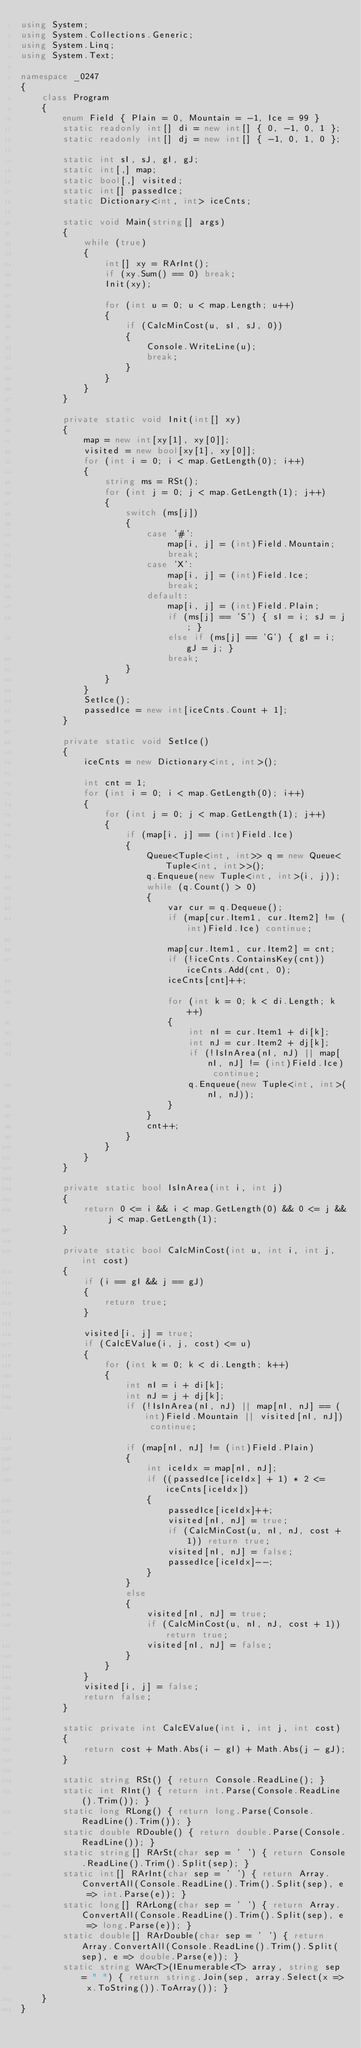<code> <loc_0><loc_0><loc_500><loc_500><_C#_>using System;
using System.Collections.Generic;
using System.Linq;
using System.Text;

namespace _0247
{
    class Program
    {
        enum Field { Plain = 0, Mountain = -1, Ice = 99 }
        static readonly int[] di = new int[] { 0, -1, 0, 1 };
        static readonly int[] dj = new int[] { -1, 0, 1, 0 };

        static int sI, sJ, gI, gJ;
        static int[,] map;
        static bool[,] visited;
        static int[] passedIce;
        static Dictionary<int, int> iceCnts;

        static void Main(string[] args)
        {
            while (true)
            {
                int[] xy = RArInt();
                if (xy.Sum() == 0) break;
                Init(xy);

                for (int u = 0; u < map.Length; u++)
                {
                    if (CalcMinCost(u, sI, sJ, 0))
                    {
                        Console.WriteLine(u);
                        break;
                    }
                }
            }
        }

        private static void Init(int[] xy)
        {
            map = new int[xy[1], xy[0]];
            visited = new bool[xy[1], xy[0]];
            for (int i = 0; i < map.GetLength(0); i++)
            {
                string ms = RSt();
                for (int j = 0; j < map.GetLength(1); j++)
                {
                    switch (ms[j])
                    {
                        case '#':
                            map[i, j] = (int)Field.Mountain;
                            break;
                        case 'X':
                            map[i, j] = (int)Field.Ice;
                            break;
                        default:
                            map[i, j] = (int)Field.Plain;
                            if (ms[j] == 'S') { sI = i; sJ = j; }
                            else if (ms[j] == 'G') { gI = i; gJ = j; }
                            break;
                    }
                }
            }
            SetIce();
            passedIce = new int[iceCnts.Count + 1];
        }

        private static void SetIce()
        {
            iceCnts = new Dictionary<int, int>();

            int cnt = 1;
            for (int i = 0; i < map.GetLength(0); i++)
            {
                for (int j = 0; j < map.GetLength(1); j++)
                {
                    if (map[i, j] == (int)Field.Ice)
                    {
                        Queue<Tuple<int, int>> q = new Queue<Tuple<int, int>>();
                        q.Enqueue(new Tuple<int, int>(i, j));
                        while (q.Count() > 0)
                        {
                            var cur = q.Dequeue();
                            if (map[cur.Item1, cur.Item2] != (int)Field.Ice) continue;

                            map[cur.Item1, cur.Item2] = cnt;
                            if (!iceCnts.ContainsKey(cnt)) iceCnts.Add(cnt, 0);
                            iceCnts[cnt]++;

                            for (int k = 0; k < di.Length; k++)
                            {
                                int nI = cur.Item1 + di[k];
                                int nJ = cur.Item2 + dj[k];
                                if (!IsInArea(nI, nJ) || map[nI, nJ] != (int)Field.Ice) continue;
                                q.Enqueue(new Tuple<int, int>(nI, nJ));
                            }
                        }
                        cnt++;
                    }
                }
            }
        }

        private static bool IsInArea(int i, int j)
        {
            return 0 <= i && i < map.GetLength(0) && 0 <= j && j < map.GetLength(1);
        }

        private static bool CalcMinCost(int u, int i, int j, int cost)
        {
            if (i == gI && j == gJ)
            {
                return true;
            }

            visited[i, j] = true;
            if (CalcEValue(i, j, cost) <= u)
            {
                for (int k = 0; k < di.Length; k++)
                {
                    int nI = i + di[k];
                    int nJ = j + dj[k];
                    if (!IsInArea(nI, nJ) || map[nI, nJ] == (int)Field.Mountain || visited[nI, nJ]) continue;

                    if (map[nI, nJ] != (int)Field.Plain)
                    {
                        int iceIdx = map[nI, nJ];
                        if ((passedIce[iceIdx] + 1) * 2 <= iceCnts[iceIdx])
                        {
                            passedIce[iceIdx]++;
                            visited[nI, nJ] = true;
                            if (CalcMinCost(u, nI, nJ, cost + 1)) return true;
                            visited[nI, nJ] = false;
                            passedIce[iceIdx]--;
                        }
                    }
                    else
                    {
                        visited[nI, nJ] = true;
                        if (CalcMinCost(u, nI, nJ, cost + 1)) return true;
                        visited[nI, nJ] = false;
                    }
                }
            }
            visited[i, j] = false;
            return false;
        }

        static private int CalcEValue(int i, int j, int cost)
        {
            return cost + Math.Abs(i - gI) + Math.Abs(j - gJ);
        }

        static string RSt() { return Console.ReadLine(); }
        static int RInt() { return int.Parse(Console.ReadLine().Trim()); }
        static long RLong() { return long.Parse(Console.ReadLine().Trim()); }
        static double RDouble() { return double.Parse(Console.ReadLine()); }
        static string[] RArSt(char sep = ' ') { return Console.ReadLine().Trim().Split(sep); }
        static int[] RArInt(char sep = ' ') { return Array.ConvertAll(Console.ReadLine().Trim().Split(sep), e => int.Parse(e)); }
        static long[] RArLong(char sep = ' ') { return Array.ConvertAll(Console.ReadLine().Trim().Split(sep), e => long.Parse(e)); }
        static double[] RArDouble(char sep = ' ') { return Array.ConvertAll(Console.ReadLine().Trim().Split(sep), e => double.Parse(e)); }
        static string WAr<T>(IEnumerable<T> array, string sep = " ") { return string.Join(sep, array.Select(x => x.ToString()).ToArray()); }
    }
}

</code> 